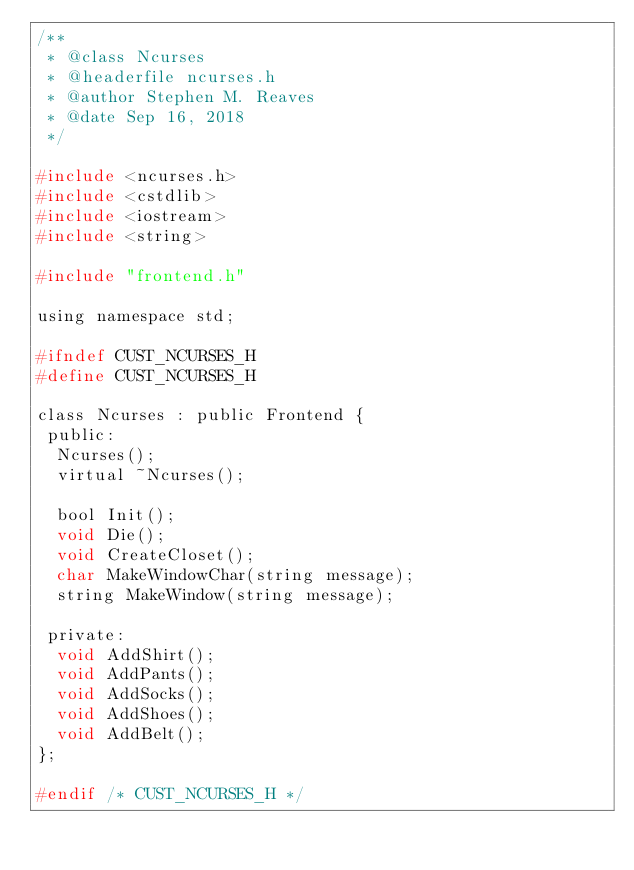Convert code to text. <code><loc_0><loc_0><loc_500><loc_500><_C_>/**
 * @class Ncurses
 * @headerfile ncurses.h
 * @author Stephen M. Reaves
 * @date Sep 16, 2018
 */

#include <ncurses.h>
#include <cstdlib>
#include <iostream>
#include <string>

#include "frontend.h"

using namespace std;

#ifndef CUST_NCURSES_H
#define CUST_NCURSES_H

class Ncurses : public Frontend {
 public:
  Ncurses();
  virtual ~Ncurses();

  bool Init();
  void Die();
  void CreateCloset();
  char MakeWindowChar(string message);
  string MakeWindow(string message);

 private:
  void AddShirt();
  void AddPants();
  void AddSocks();
  void AddShoes();
  void AddBelt();
};

#endif /* CUST_NCURSES_H */
</code> 